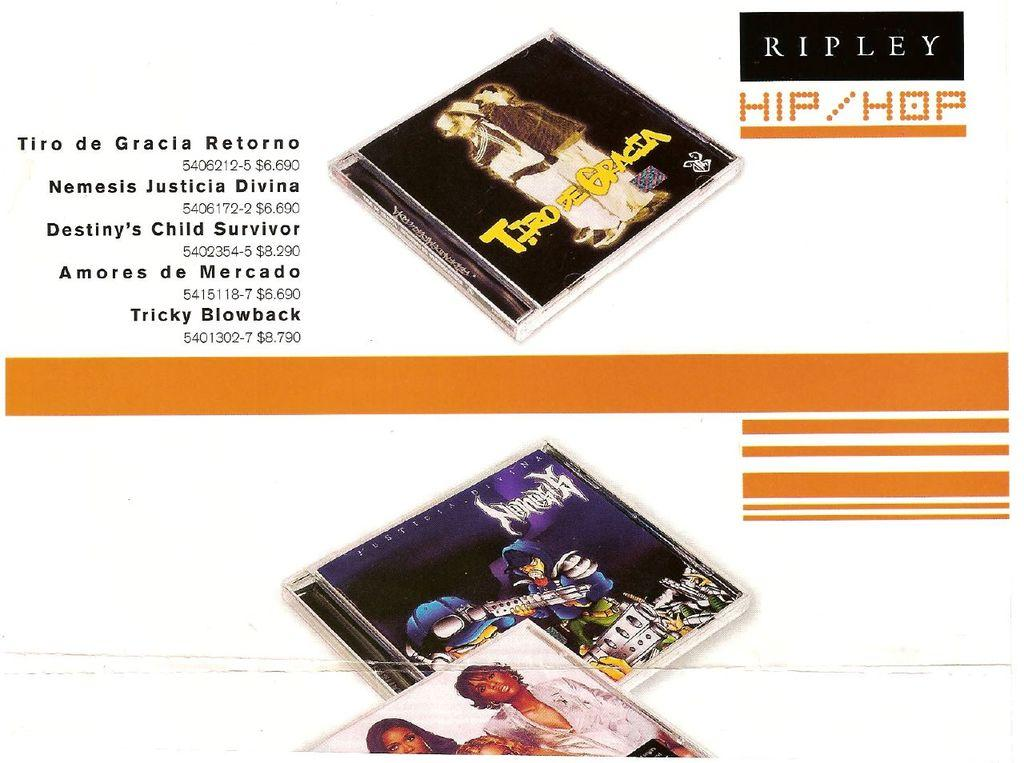What type of object is present at the top and bottom of the image? There are cassettes at the top and bottom of the image. What is written on the right side of the image? There is text written on the right side of the image. What is written on the left side of the image? There is text written on the left side of the image. Is there a fire burning in the image? No, there is no fire present in the image. Can you see someone taking a bath in the image? No, there is no bath or person taking a bath in the image. 